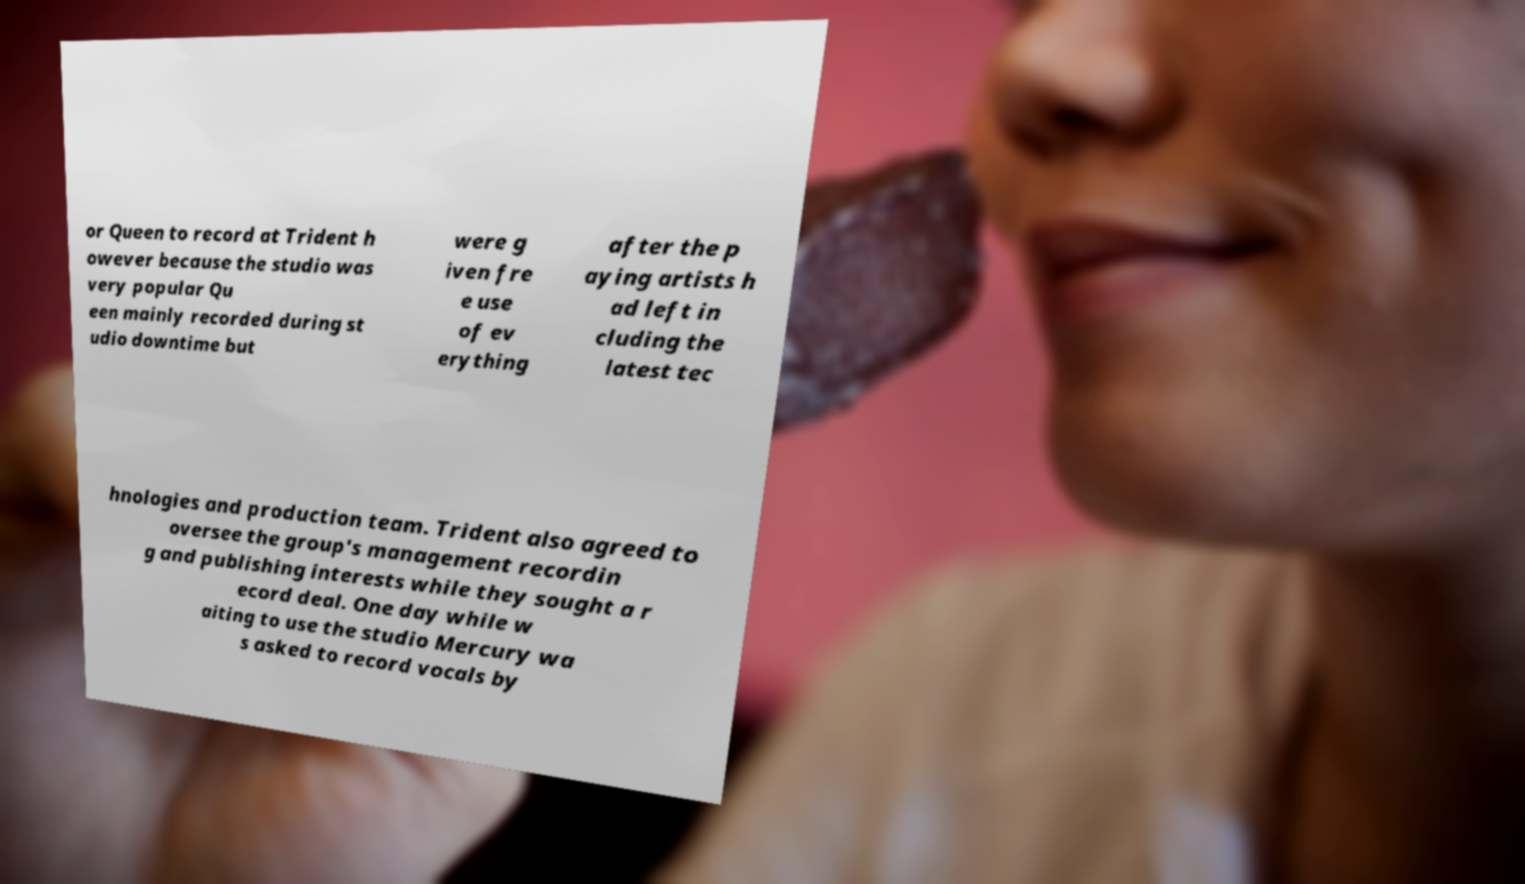Could you extract and type out the text from this image? or Queen to record at Trident h owever because the studio was very popular Qu een mainly recorded during st udio downtime but were g iven fre e use of ev erything after the p aying artists h ad left in cluding the latest tec hnologies and production team. Trident also agreed to oversee the group's management recordin g and publishing interests while they sought a r ecord deal. One day while w aiting to use the studio Mercury wa s asked to record vocals by 